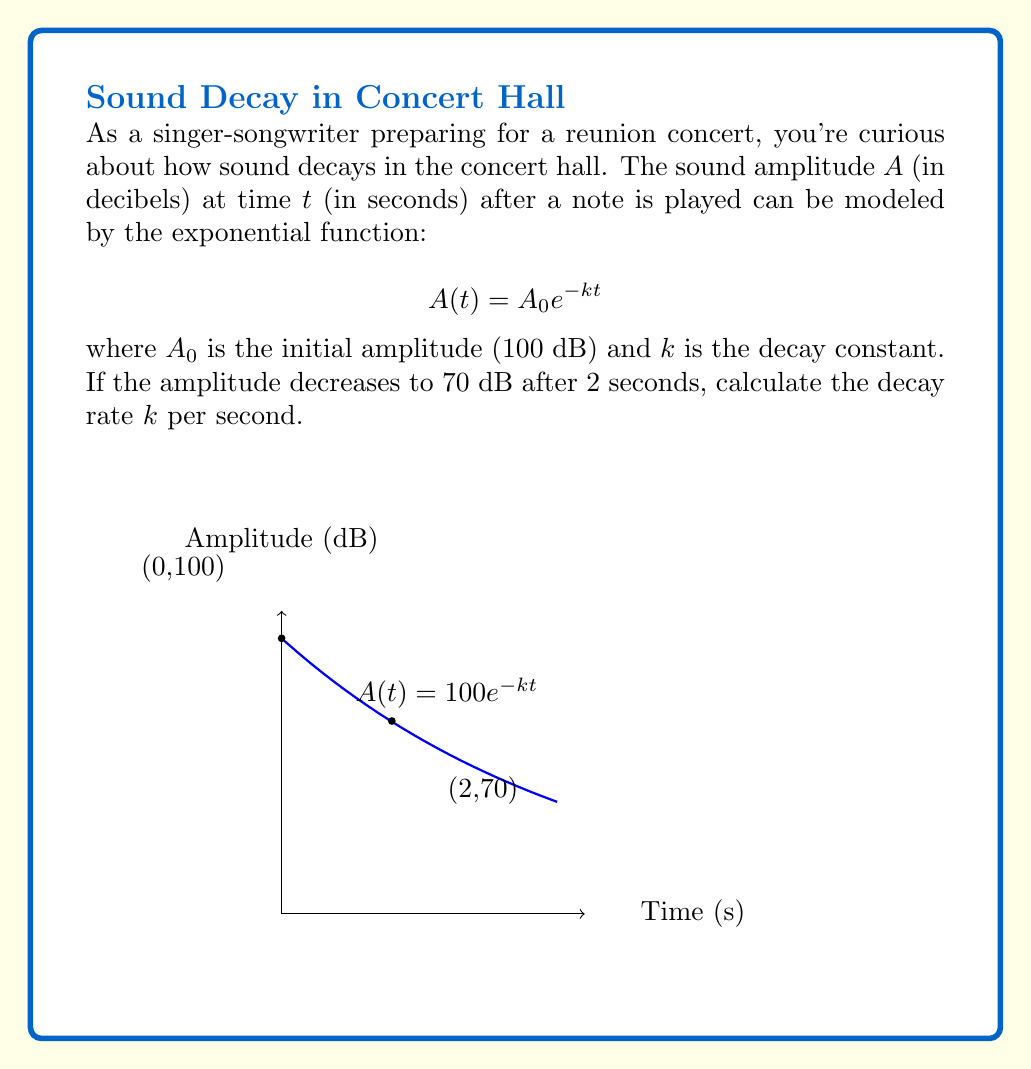Show me your answer to this math problem. Let's approach this step-by-step:

1) We start with the exponential decay function:
   $$A(t) = A_0 e^{-kt}$$

2) We know the initial amplitude $A_0 = 100$ dB and after 2 seconds, $A(2) = 70$ dB. Let's substitute these values:
   $$70 = 100 e^{-k(2)}$$

3) Divide both sides by 100:
   $$0.7 = e^{-2k}$$

4) Take the natural logarithm of both sides:
   $$\ln(0.7) = -2k$$

5) Solve for $k$:
   $$k = -\frac{\ln(0.7)}{2}$$

6) Calculate the value of $k$:
   $$k = -\frac{\ln(0.7)}{2} \approx 0.1783$$

This means the amplitude decays at a rate of approximately 0.1783 per second.
Answer: $k \approx 0.1783$ s^(-1) 